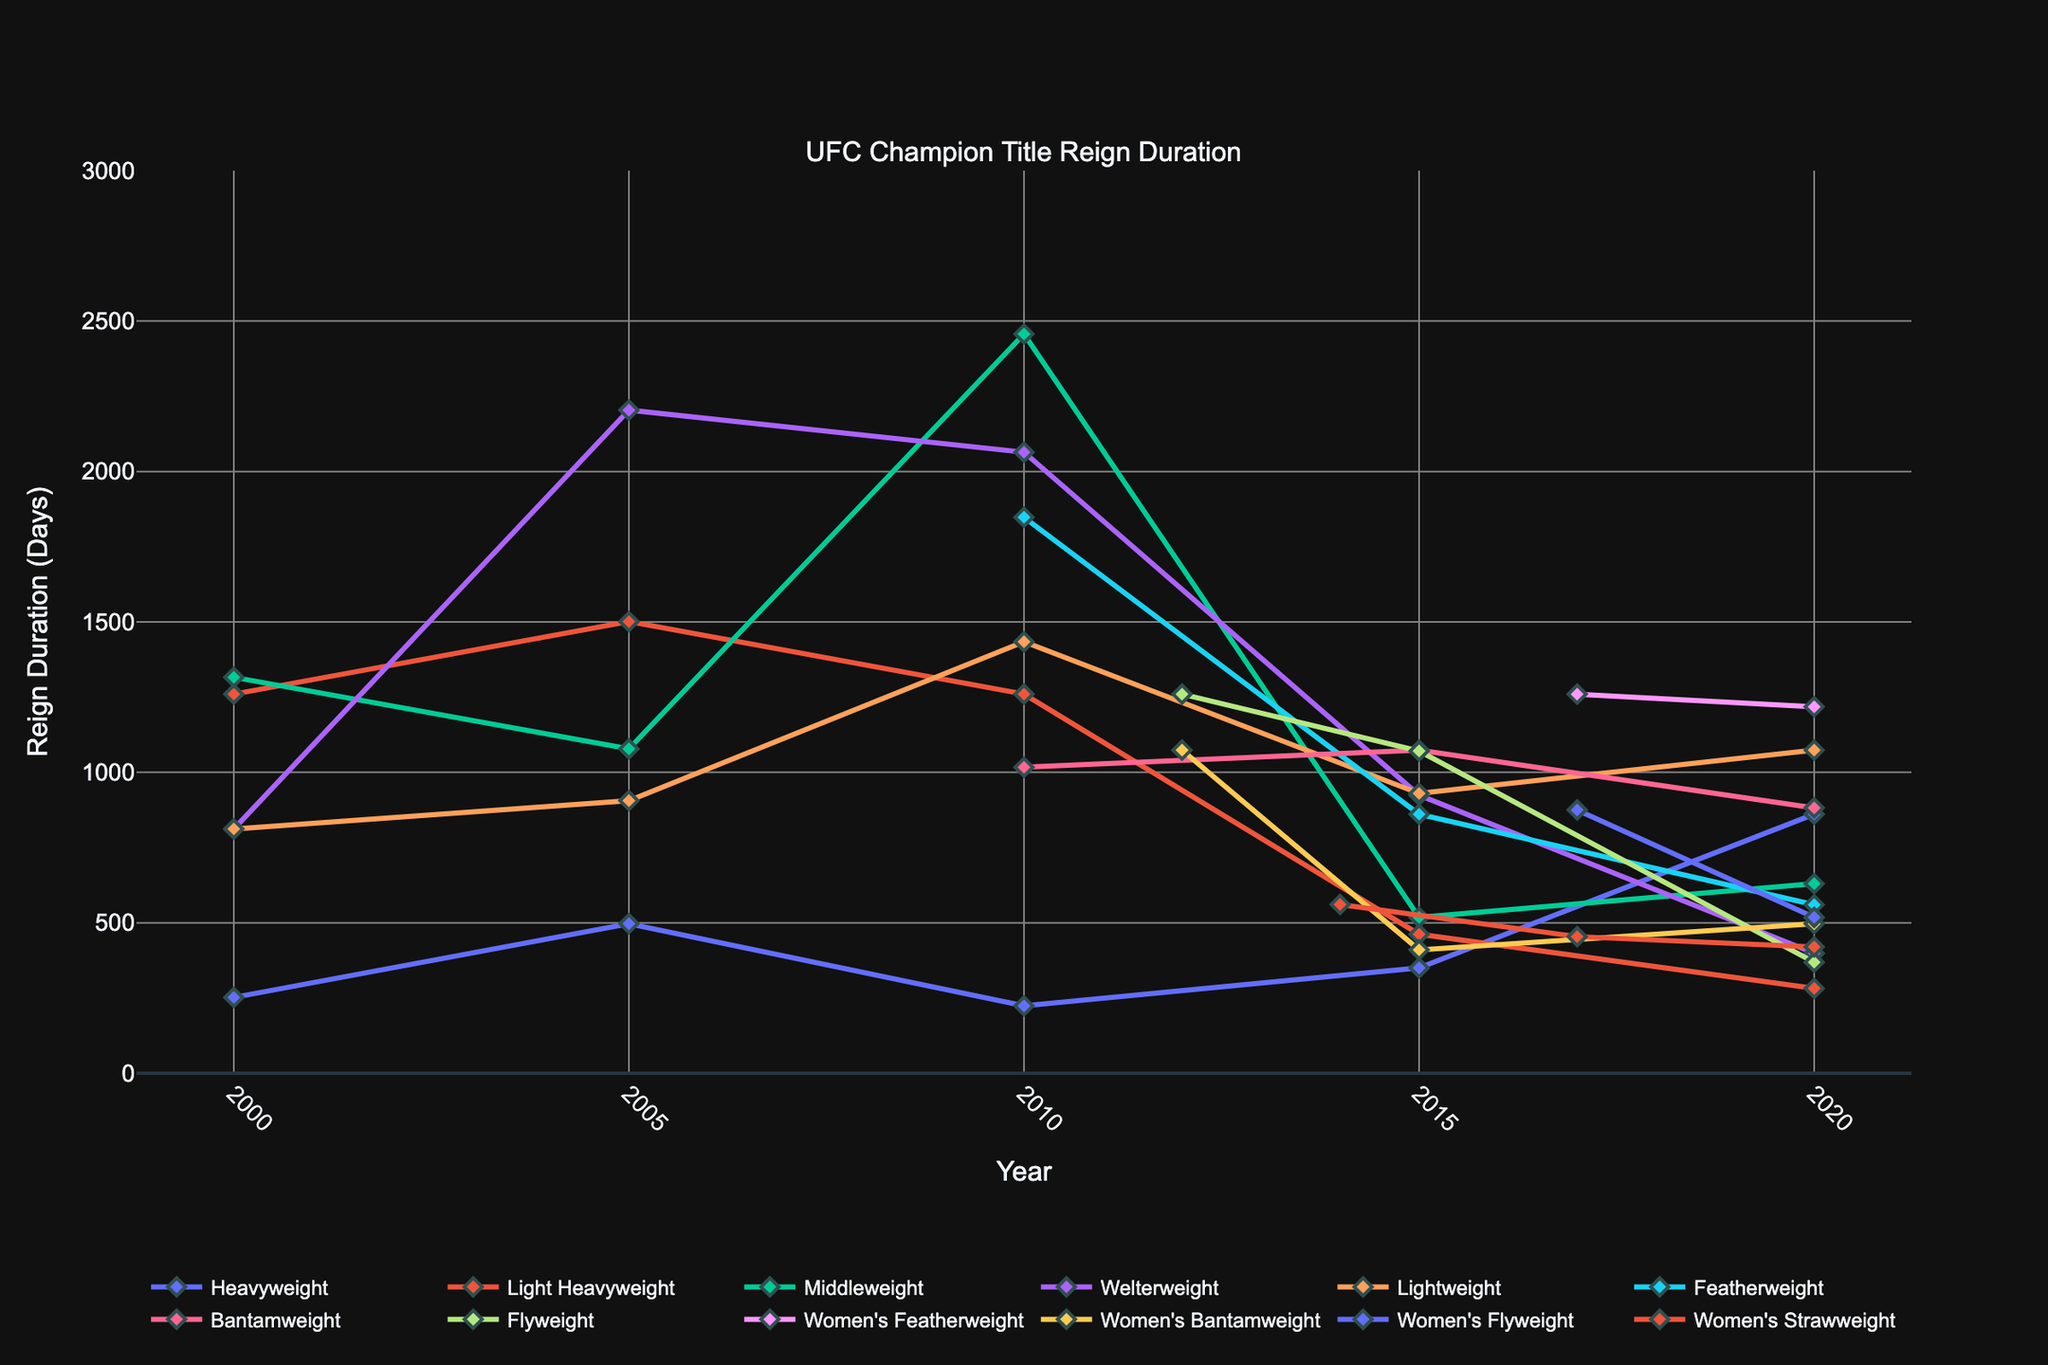Which weight class had the longest title reign duration in 2010? Examine the data points for each weight class in the year 2010. The Middleweight class had the longest title reign duration of 2457 days.
Answer: Middleweight How did the reign duration for Heavyweights change from 2000 to 2020? Observe the line plot for Heavyweight across the years. The reign duration increased from 252 days in 2000 to 861 days in 2020.
Answer: Increased Which weight class had the most significant decrease in title reign duration from 2015 to 2020? Identify the differences in reign durations for each weight class between 2015 and 2020. The Welterweight class decreased from 924 days in 2015 to 399 days in 2020, a difference of 525 days.
Answer: Welterweight Compare the Welterweight title reign duration in 2005 to the Flyweight title reign duration in 2015. Which one is longer and by how much? Check the data points for Welterweight in 2005 (2204 days) and Flyweight in 2015 (1071 days). The Welterweight reign is longer by 1133 days.
Answer: Welterweight, 1133 days How does the reign duration for the Women's Featherweight class in 2017 compare to the Bantamweight class in 2010? Look at the data points for Women's Featherweight in 2017 (1260 days) and Bantamweight in 2010 (1017 days). The Women's Featherweight reign is longer by 243 days.
Answer: Women's Featherweight, 243 days Which weight class had the shortest title reign duration in 2020? Inspect the data points for all classes in 2020. The Women's Strawweight has the shortest reign duration of 420 days.
Answer: Women's Strawweight How did the Lightweight reign duration change from 2000 to 2010? Observe the line plot for Lightweight from 2000 (812 days) to 2010 (1434 days). The duration increased by 622 days.
Answer: Increased, 622 days What is the average title reign duration for the Flyweight class from 2012 to 2020? Calculate the average of the Flyweight reign durations: (1260 + 1071 + 369) / 3 = 900 days.
Answer: 900 days Which class had a more consistent reign duration (less fluctuation) between 2000 and 2020: Middleweight or Light Heavyweight? Compare the vertical range (difference between max and min values) of Middleweight (2457-518 = 1939 days) and Light Heavyweight (1501-282 = 1219 days). Light Heavyweight shows less fluctuation.
Answer: Light Heavyweight Amongst Featherweight, Bantamweight, and Flyweight, which weight class had the longest reign duration in 2010? Compare the title reign durations in 2010 for Featherweight (1848 days), Bantamweight (1017 days), and Flyweight (N/A since it starts in 2012). Featherweight had the longest duration.
Answer: Featherweight 